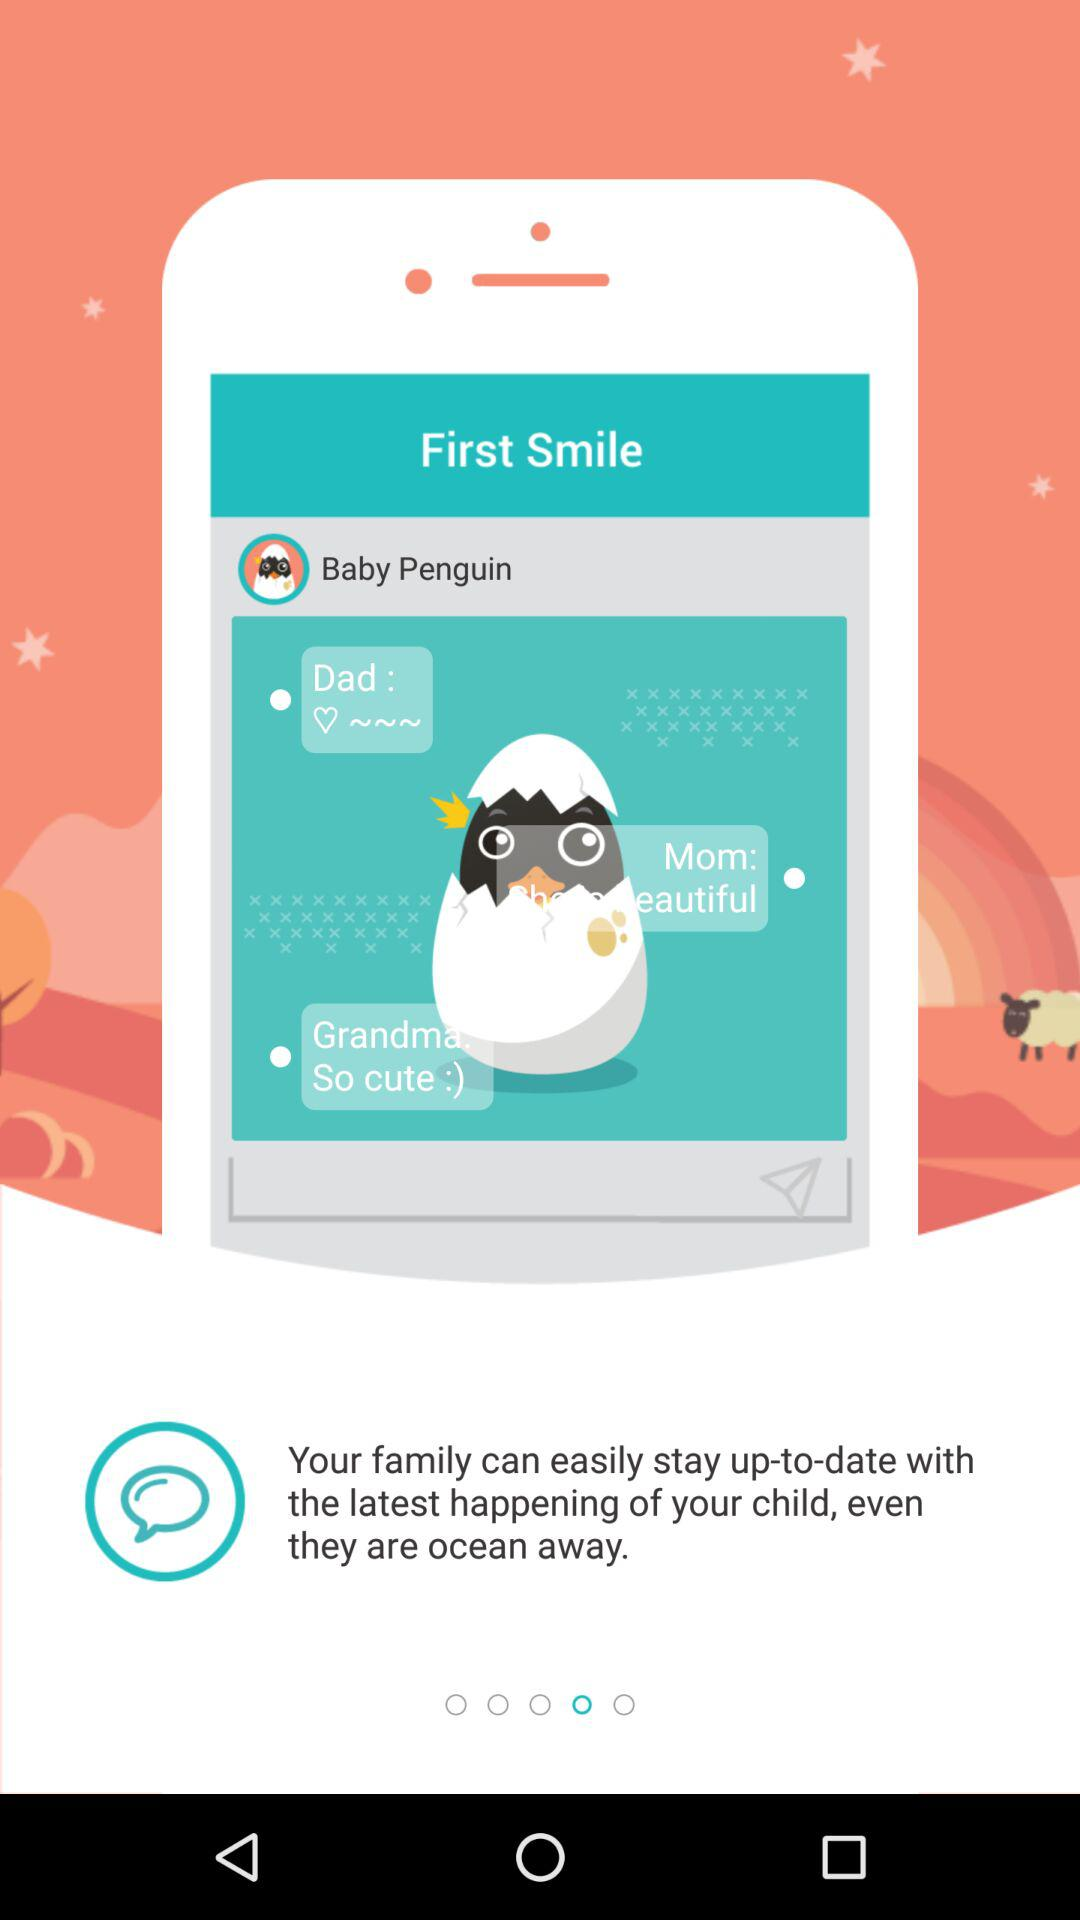What is the app name? The app name is "First Smile". 